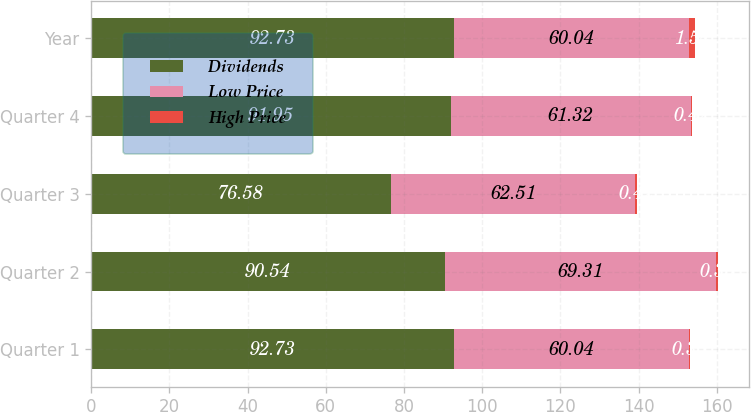Convert chart to OTSL. <chart><loc_0><loc_0><loc_500><loc_500><stacked_bar_chart><ecel><fcel>Quarter 1<fcel>Quarter 2<fcel>Quarter 3<fcel>Quarter 4<fcel>Year<nl><fcel>Dividends<fcel>92.73<fcel>90.54<fcel>76.58<fcel>91.95<fcel>92.73<nl><fcel>Low Price<fcel>60.04<fcel>69.31<fcel>62.51<fcel>61.32<fcel>60.04<nl><fcel>High Price<fcel>0.35<fcel>0.35<fcel>0.42<fcel>0.42<fcel>1.54<nl></chart> 